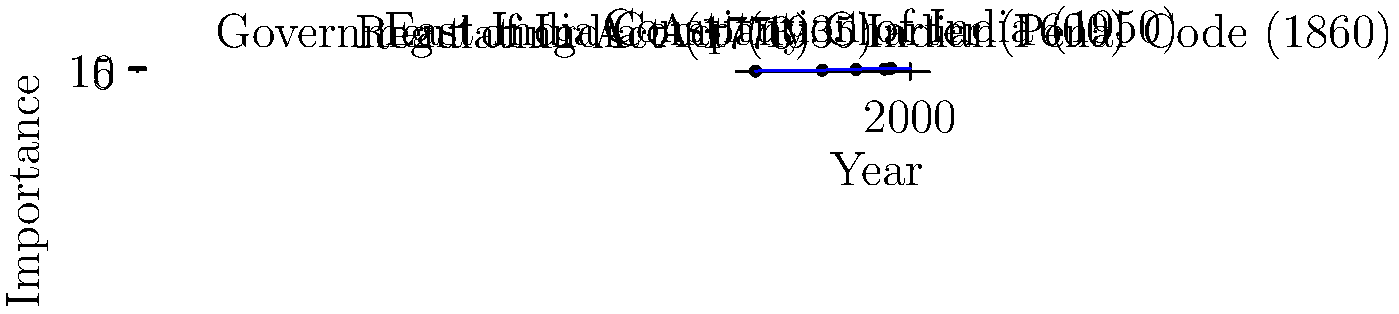Based on the graph showing the timeline of significant legal events in Indian history, which event appears to have the highest importance rating, and in which year did it occur? To answer this question, we need to analyze the graph carefully:

1. The x-axis represents the years from 1550 to 2050.
2. The y-axis represents the importance rating from 0 to 10.
3. There are five events plotted on the graph:
   a) East India Company Charter (1600)
   b) Regulating Act (1773)
   c) Indian Penal Code (1860)
   d) Government of India Act (1935)
   e) Constitution of India (1950)

4. Among these events, we need to identify the one with the highest y-coordinate (importance rating).

5. Examining the graph, we can see that the point representing the Constitution of India in 1950 is placed highest on the y-axis.

6. The importance rating for the Constitution of India appears to be 9 out of 10, which is the highest among all the events shown.

Therefore, the event with the highest importance rating is the Constitution of India, which occurred in 1950.
Answer: Constitution of India (1950) 